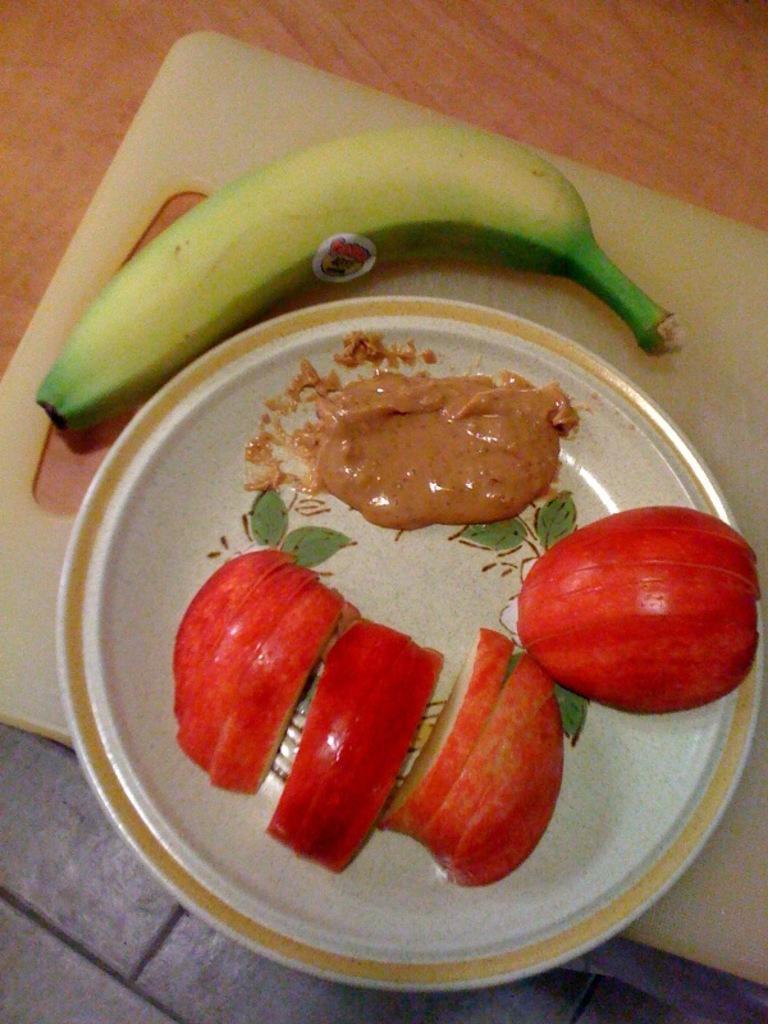How would you summarize this image in a sentence or two? In this image there are slices of apple and sauce on the plate, beside the plate there is a banana on a chopping board. 